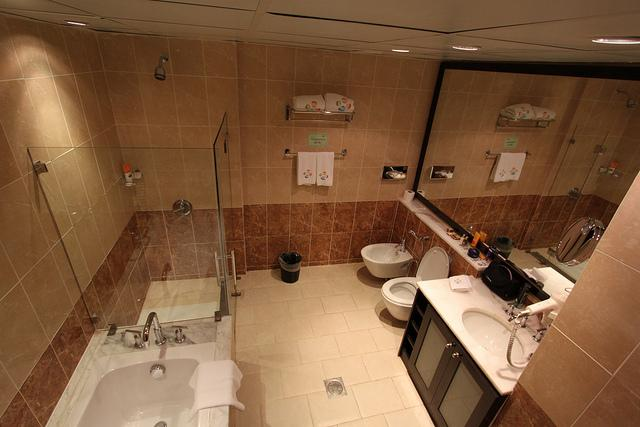What kind of bathroom is this? Please explain your reasoning. hotel. The bathroom looks very large and fancy. 